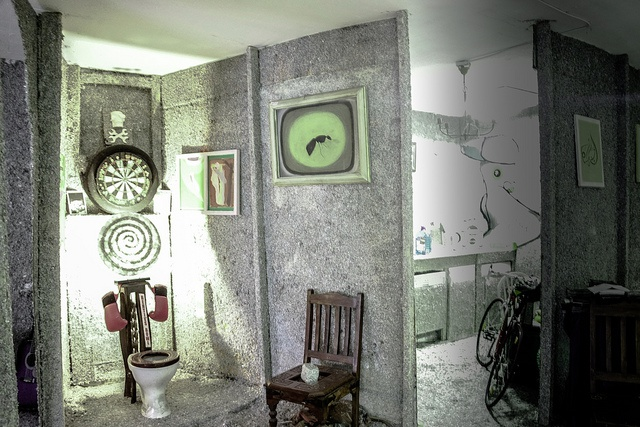Describe the objects in this image and their specific colors. I can see chair in gray, black, and darkgray tones, bicycle in gray and black tones, and toilet in gray, darkgray, and black tones in this image. 